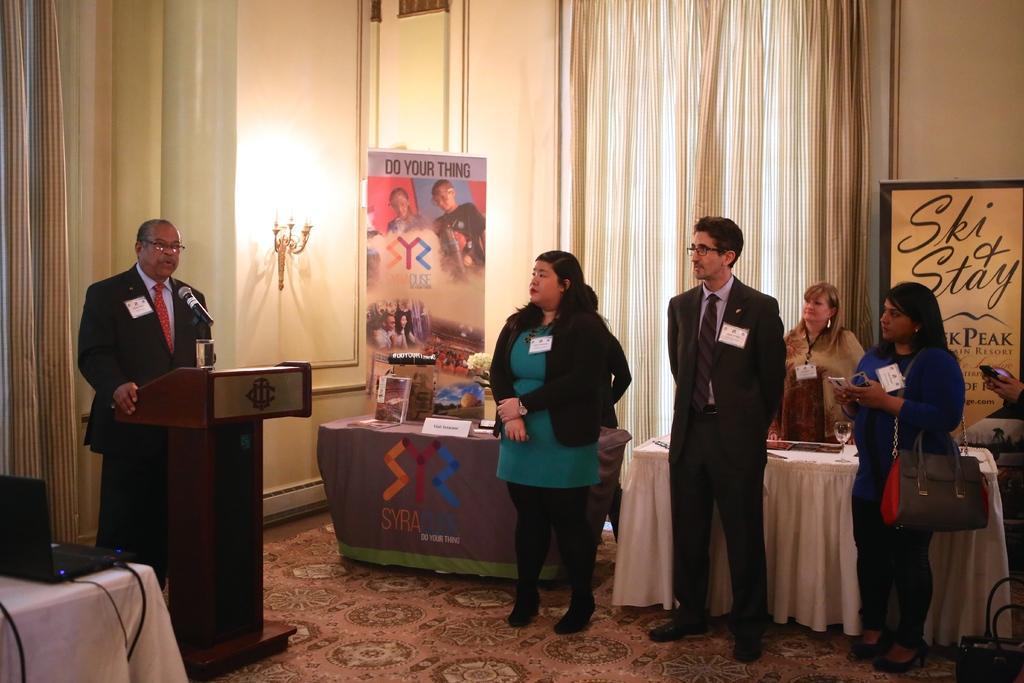In one or two sentences, can you explain what this image depicts? This is a picture taken in a room, there are group of people standing on a floor and a man in black blazer standing behind the podium on the podium there are glass and microphone. Background of this people there are the tables, banner and a wall on there wall there are the lamp and curtains. 